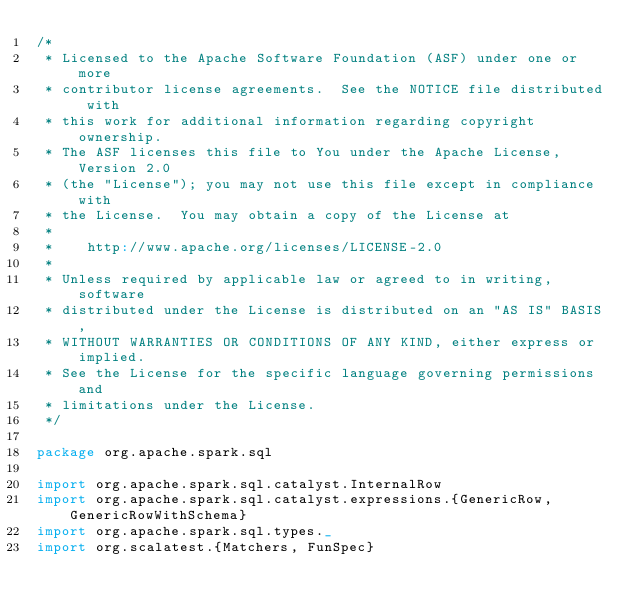Convert code to text. <code><loc_0><loc_0><loc_500><loc_500><_Scala_>/*
 * Licensed to the Apache Software Foundation (ASF) under one or more
 * contributor license agreements.  See the NOTICE file distributed with
 * this work for additional information regarding copyright ownership.
 * The ASF licenses this file to You under the Apache License, Version 2.0
 * (the "License"); you may not use this file except in compliance with
 * the License.  You may obtain a copy of the License at
 *
 *    http://www.apache.org/licenses/LICENSE-2.0
 *
 * Unless required by applicable law or agreed to in writing, software
 * distributed under the License is distributed on an "AS IS" BASIS,
 * WITHOUT WARRANTIES OR CONDITIONS OF ANY KIND, either express or implied.
 * See the License for the specific language governing permissions and
 * limitations under the License.
 */

package org.apache.spark.sql

import org.apache.spark.sql.catalyst.InternalRow
import org.apache.spark.sql.catalyst.expressions.{GenericRow, GenericRowWithSchema}
import org.apache.spark.sql.types._
import org.scalatest.{Matchers, FunSpec}
</code> 